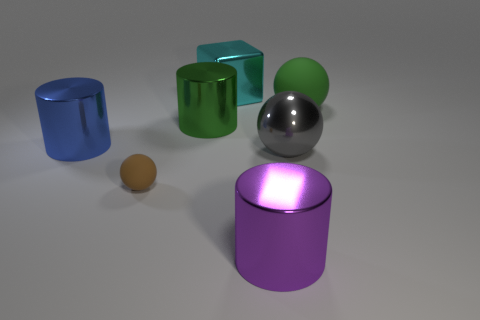Which object in the image appears to be closest to the light source? The purple cylinder seems to be the closest to the light source. This is evidenced by its bright top surface which indicates it is reflecting a significant amount of light. 